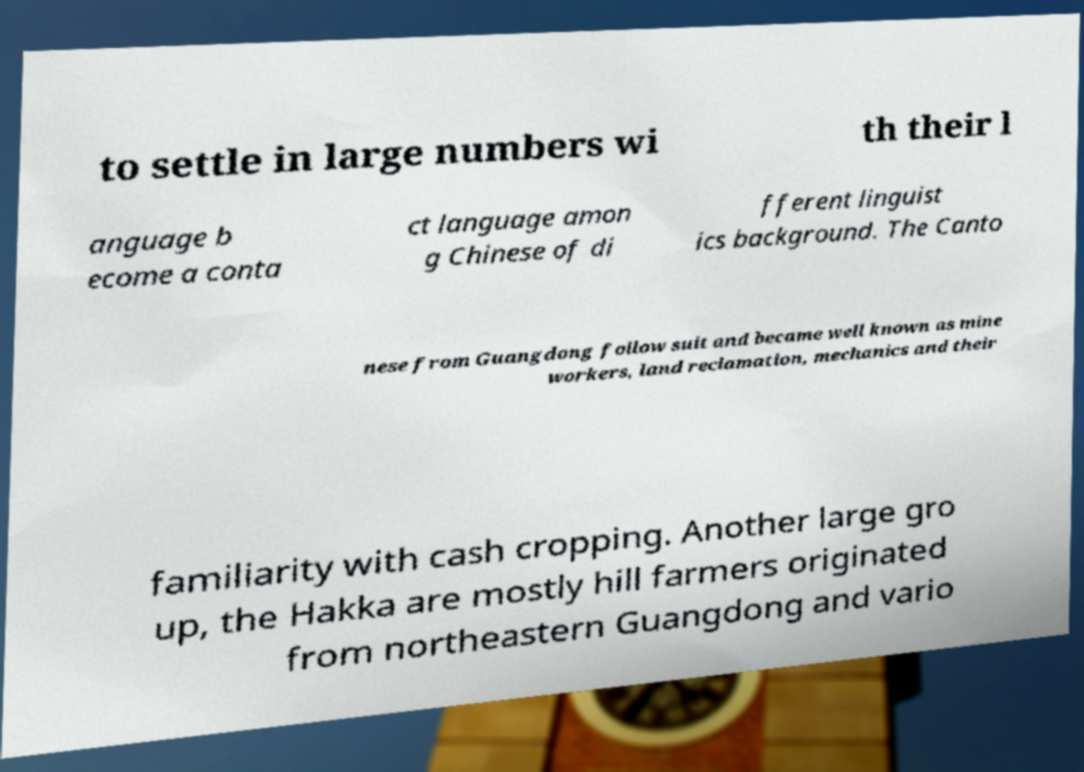For documentation purposes, I need the text within this image transcribed. Could you provide that? to settle in large numbers wi th their l anguage b ecome a conta ct language amon g Chinese of di fferent linguist ics background. The Canto nese from Guangdong follow suit and became well known as mine workers, land reclamation, mechanics and their familiarity with cash cropping. Another large gro up, the Hakka are mostly hill farmers originated from northeastern Guangdong and vario 